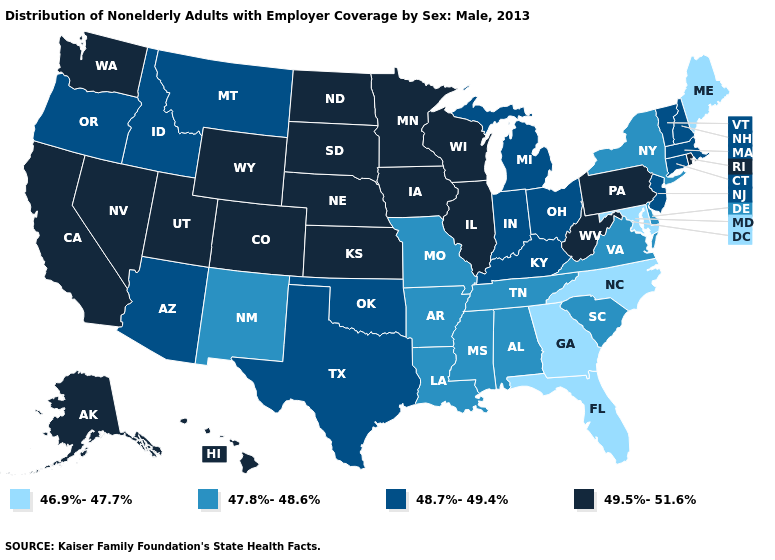What is the value of Massachusetts?
Write a very short answer. 48.7%-49.4%. What is the value of Pennsylvania?
Quick response, please. 49.5%-51.6%. What is the highest value in the South ?
Keep it brief. 49.5%-51.6%. Name the states that have a value in the range 47.8%-48.6%?
Be succinct. Alabama, Arkansas, Delaware, Louisiana, Mississippi, Missouri, New Mexico, New York, South Carolina, Tennessee, Virginia. Which states have the highest value in the USA?
Write a very short answer. Alaska, California, Colorado, Hawaii, Illinois, Iowa, Kansas, Minnesota, Nebraska, Nevada, North Dakota, Pennsylvania, Rhode Island, South Dakota, Utah, Washington, West Virginia, Wisconsin, Wyoming. Which states have the lowest value in the MidWest?
Answer briefly. Missouri. Name the states that have a value in the range 48.7%-49.4%?
Give a very brief answer. Arizona, Connecticut, Idaho, Indiana, Kentucky, Massachusetts, Michigan, Montana, New Hampshire, New Jersey, Ohio, Oklahoma, Oregon, Texas, Vermont. Name the states that have a value in the range 46.9%-47.7%?
Keep it brief. Florida, Georgia, Maine, Maryland, North Carolina. Does Montana have a lower value than Hawaii?
Give a very brief answer. Yes. Which states have the highest value in the USA?
Concise answer only. Alaska, California, Colorado, Hawaii, Illinois, Iowa, Kansas, Minnesota, Nebraska, Nevada, North Dakota, Pennsylvania, Rhode Island, South Dakota, Utah, Washington, West Virginia, Wisconsin, Wyoming. Which states have the lowest value in the USA?
Keep it brief. Florida, Georgia, Maine, Maryland, North Carolina. What is the lowest value in the USA?
Keep it brief. 46.9%-47.7%. Does the map have missing data?
Answer briefly. No. How many symbols are there in the legend?
Give a very brief answer. 4. 